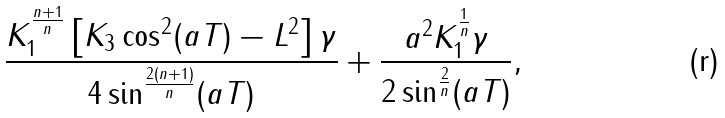<formula> <loc_0><loc_0><loc_500><loc_500>\frac { K _ { 1 } ^ { \frac { n + 1 } { n } } \left [ K _ { 3 } \cos ^ { 2 } ( a T ) - L ^ { 2 } \right ] \gamma } { 4 \sin ^ { \frac { 2 ( n + 1 ) } { n } } ( a T ) } + \frac { a ^ { 2 } K _ { 1 } ^ { \frac { 1 } { n } } \gamma } { 2 \sin ^ { \frac { 2 } { n } } ( a T ) } ,</formula> 